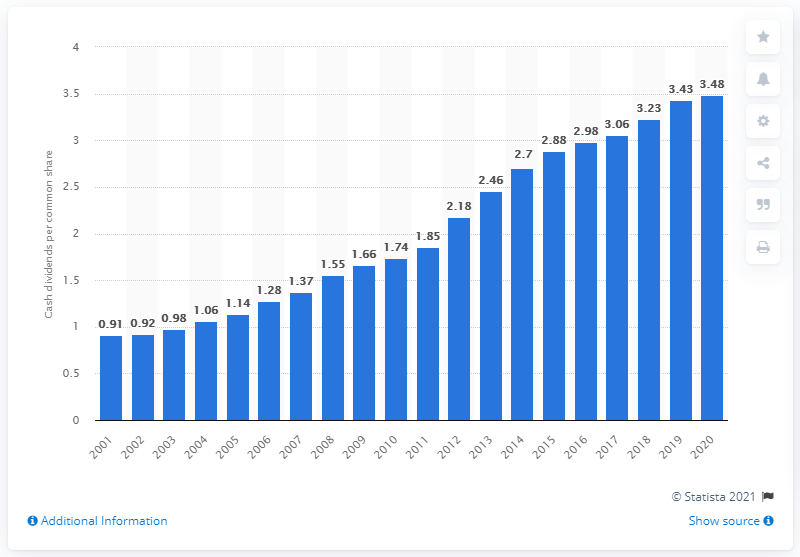Highlight a few significant elements in this photo. ExxonMobil declared a cash dividend per common share of 3.48 in 2020. 